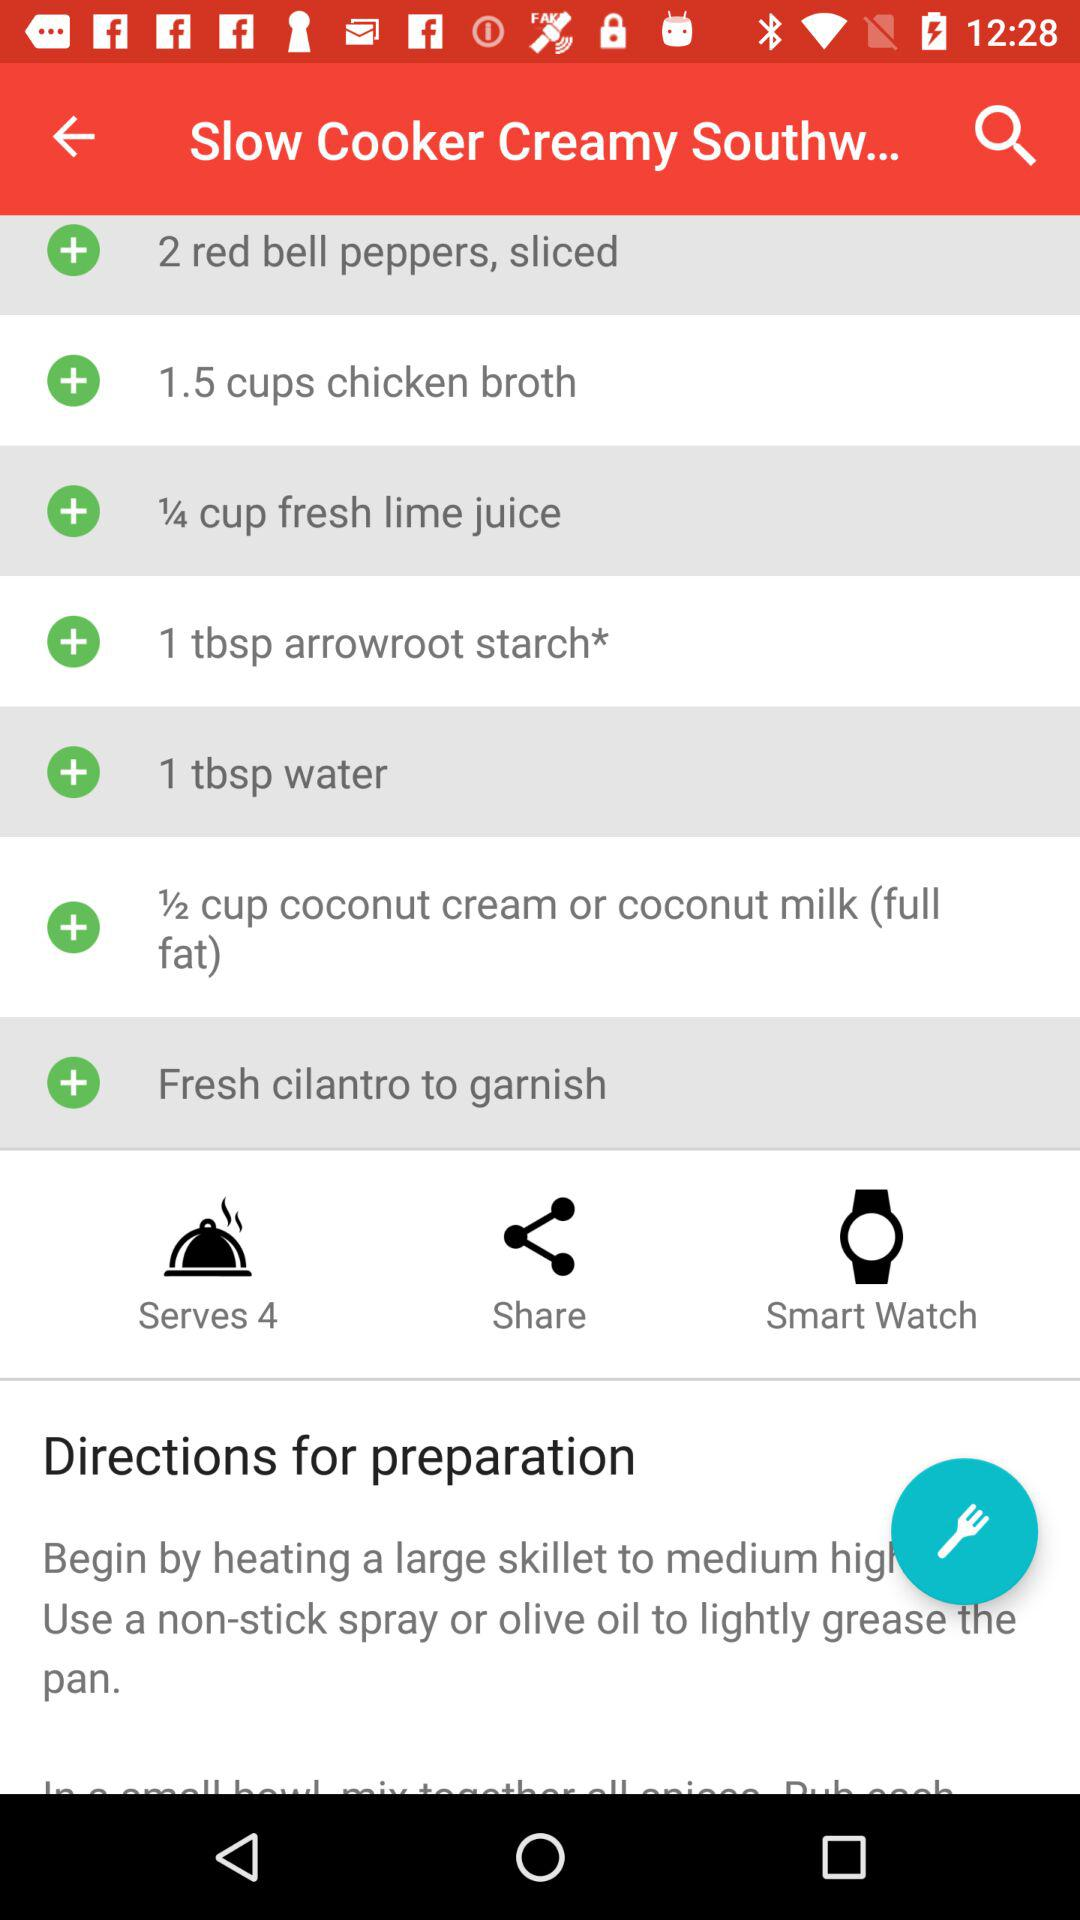How many people can the dish be served to? The dish can be served to 4 people. 